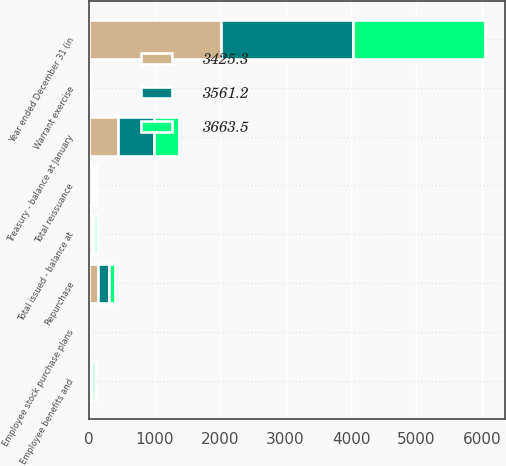Convert chart. <chart><loc_0><loc_0><loc_500><loc_500><stacked_bar_chart><ecel><fcel>Year ended December 31 (in<fcel>Total issued - balance at<fcel>Treasury - balance at January<fcel>Repurchase<fcel>Employee benefits and<fcel>Warrant exercise<fcel>Employee stock purchase plans<fcel>Total reissuance<nl><fcel>3561.2<fcel>2017<fcel>38.1<fcel>543.7<fcel>166.6<fcel>24.5<fcel>5.4<fcel>0.8<fcel>30.7<nl><fcel>3425.3<fcel>2016<fcel>38.1<fcel>441.4<fcel>140.4<fcel>26<fcel>11.1<fcel>1<fcel>38.1<nl><fcel>3663.5<fcel>2015<fcel>38.1<fcel>390.1<fcel>89.8<fcel>32.8<fcel>4.7<fcel>1<fcel>38.5<nl></chart> 